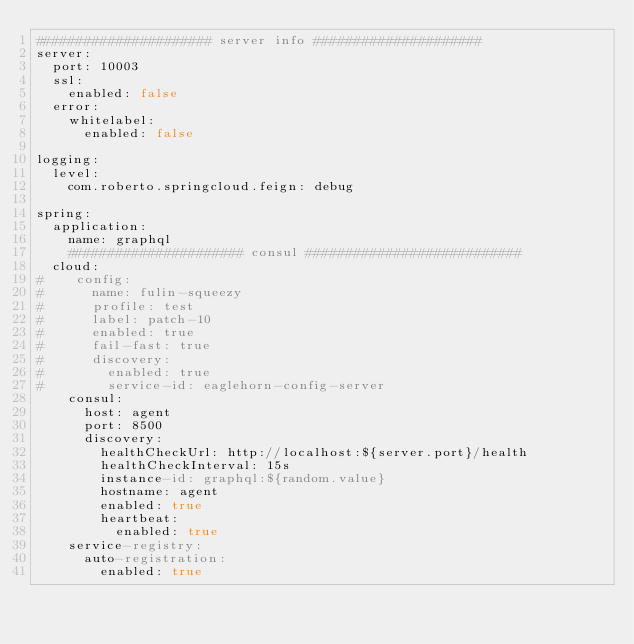<code> <loc_0><loc_0><loc_500><loc_500><_YAML_>###################### server info #####################
server:
  port: 10003
  ssl:
    enabled: false
  error:
    whitelabel:
      enabled: false

logging:
  level:
    com.roberto.springcloud.feign: debug

spring:
  application:
    name: graphql
    ###################### consul ###########################
  cloud:
#    config:
#      name: fulin-squeezy
#      profile: test
#      label: patch-10
#      enabled: true
#      fail-fast: true
#      discovery:
#        enabled: true
#        service-id: eaglehorn-config-server
    consul:
      host: agent
      port: 8500
      discovery:
        healthCheckUrl: http://localhost:${server.port}/health
        healthCheckInterval: 15s
        instance-id: graphql:${random.value}
        hostname: agent
        enabled: true
        heartbeat:
          enabled: true
    service-registry:
      auto-registration:
        enabled: true</code> 